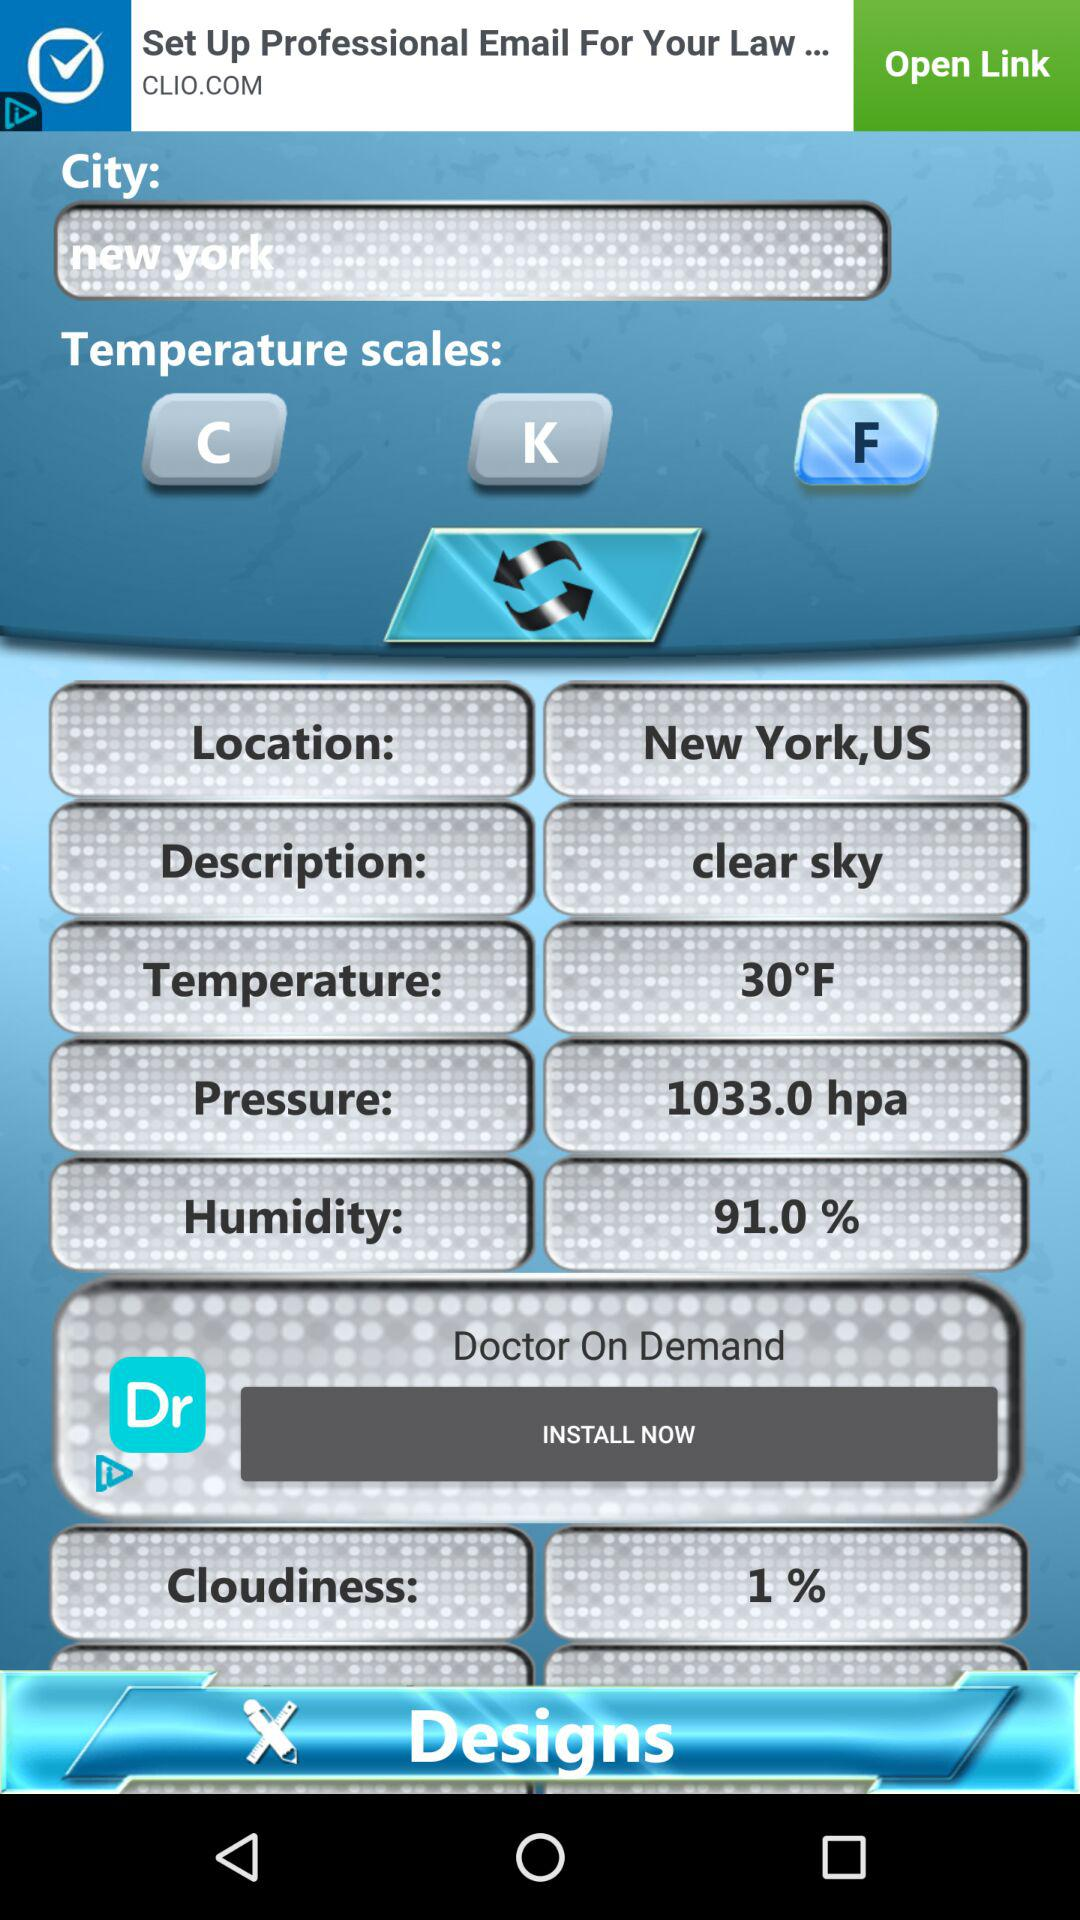What is the temperature in New York? The temperature is 30 °F. 